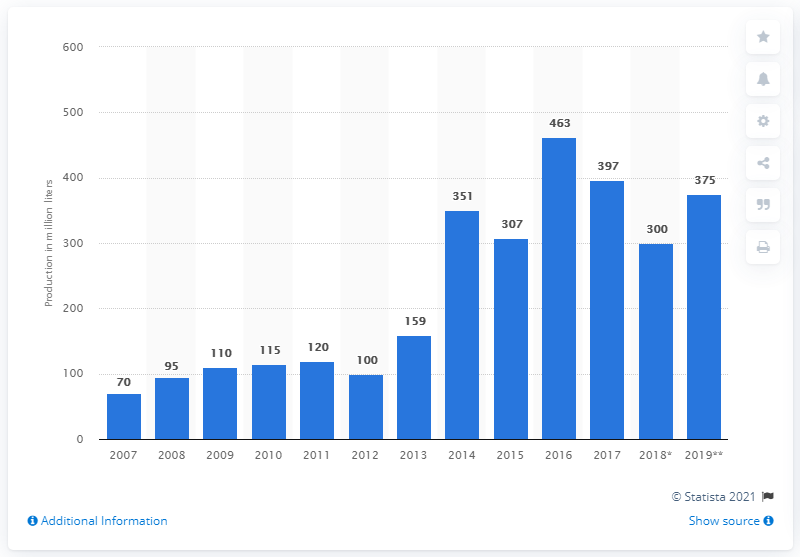Indicate a few pertinent items in this graphic. The forecast production of biodiesel in Canada in 2019 is expected to be approximately 375 million liters. In 2017, the production volume of biodiesel in Canada was 397. 